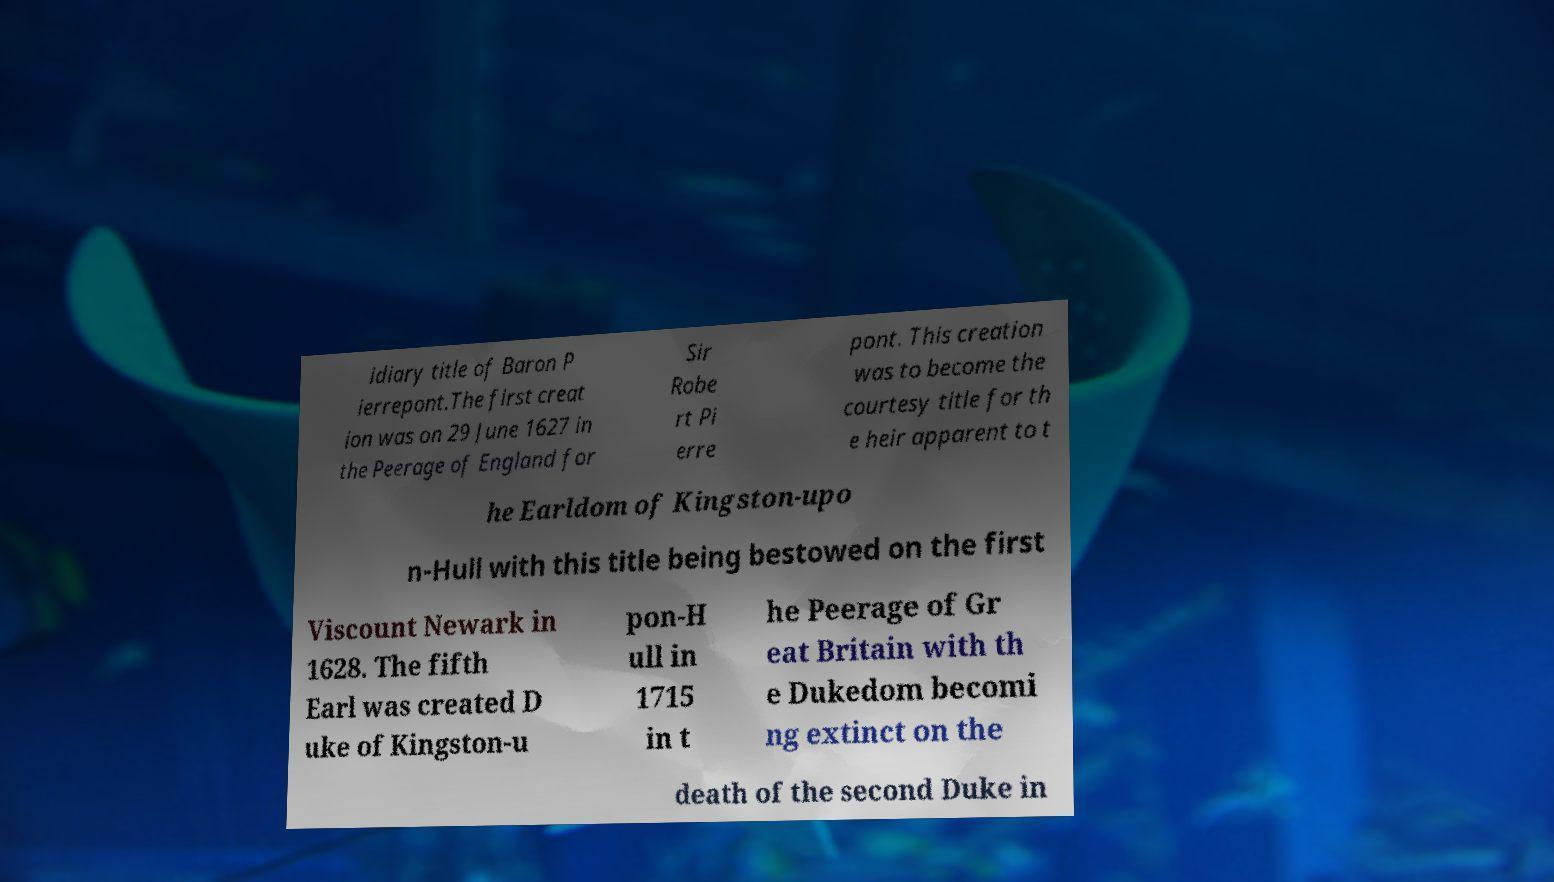Could you extract and type out the text from this image? idiary title of Baron P ierrepont.The first creat ion was on 29 June 1627 in the Peerage of England for Sir Robe rt Pi erre pont. This creation was to become the courtesy title for th e heir apparent to t he Earldom of Kingston-upo n-Hull with this title being bestowed on the first Viscount Newark in 1628. The fifth Earl was created D uke of Kingston-u pon-H ull in 1715 in t he Peerage of Gr eat Britain with th e Dukedom becomi ng extinct on the death of the second Duke in 